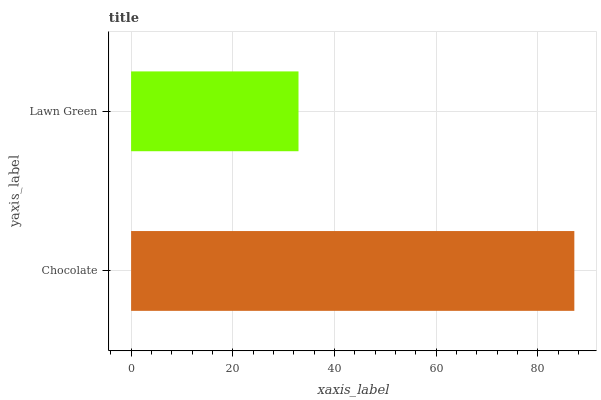Is Lawn Green the minimum?
Answer yes or no. Yes. Is Chocolate the maximum?
Answer yes or no. Yes. Is Lawn Green the maximum?
Answer yes or no. No. Is Chocolate greater than Lawn Green?
Answer yes or no. Yes. Is Lawn Green less than Chocolate?
Answer yes or no. Yes. Is Lawn Green greater than Chocolate?
Answer yes or no. No. Is Chocolate less than Lawn Green?
Answer yes or no. No. Is Chocolate the high median?
Answer yes or no. Yes. Is Lawn Green the low median?
Answer yes or no. Yes. Is Lawn Green the high median?
Answer yes or no. No. Is Chocolate the low median?
Answer yes or no. No. 